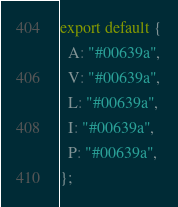Convert code to text. <code><loc_0><loc_0><loc_500><loc_500><_JavaScript_>export default {
  A: "#00639a",
  V: "#00639a",
  L: "#00639a",
  I: "#00639a",
  P: "#00639a",
};
</code> 